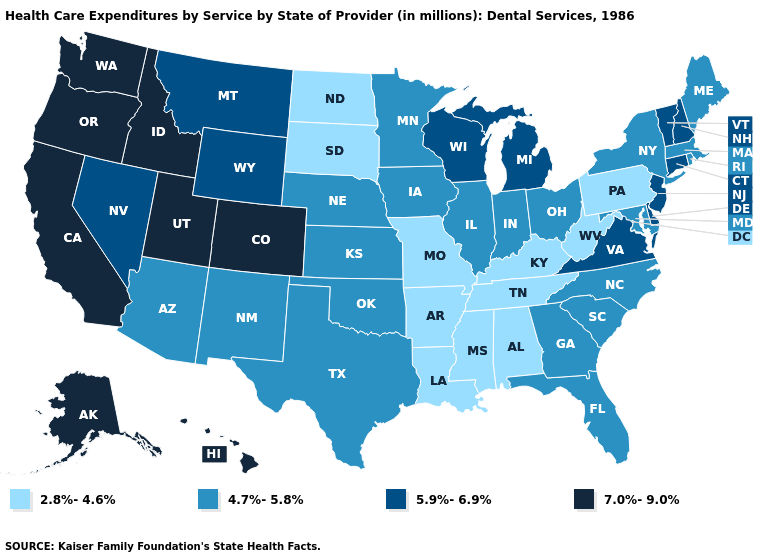Name the states that have a value in the range 7.0%-9.0%?
Be succinct. Alaska, California, Colorado, Hawaii, Idaho, Oregon, Utah, Washington. What is the value of Pennsylvania?
Short answer required. 2.8%-4.6%. What is the highest value in the Northeast ?
Concise answer only. 5.9%-6.9%. Does the map have missing data?
Keep it brief. No. Does Idaho have a higher value than Hawaii?
Write a very short answer. No. Does North Carolina have the lowest value in the USA?
Give a very brief answer. No. What is the value of Virginia?
Write a very short answer. 5.9%-6.9%. Does New Hampshire have the same value as Wisconsin?
Concise answer only. Yes. Name the states that have a value in the range 4.7%-5.8%?
Keep it brief. Arizona, Florida, Georgia, Illinois, Indiana, Iowa, Kansas, Maine, Maryland, Massachusetts, Minnesota, Nebraska, New Mexico, New York, North Carolina, Ohio, Oklahoma, Rhode Island, South Carolina, Texas. Name the states that have a value in the range 5.9%-6.9%?
Give a very brief answer. Connecticut, Delaware, Michigan, Montana, Nevada, New Hampshire, New Jersey, Vermont, Virginia, Wisconsin, Wyoming. Which states have the lowest value in the USA?
Answer briefly. Alabama, Arkansas, Kentucky, Louisiana, Mississippi, Missouri, North Dakota, Pennsylvania, South Dakota, Tennessee, West Virginia. What is the highest value in states that border Missouri?
Concise answer only. 4.7%-5.8%. Does the map have missing data?
Be succinct. No. Does California have the same value as Washington?
Give a very brief answer. Yes. Does Indiana have the same value as New Jersey?
Be succinct. No. 